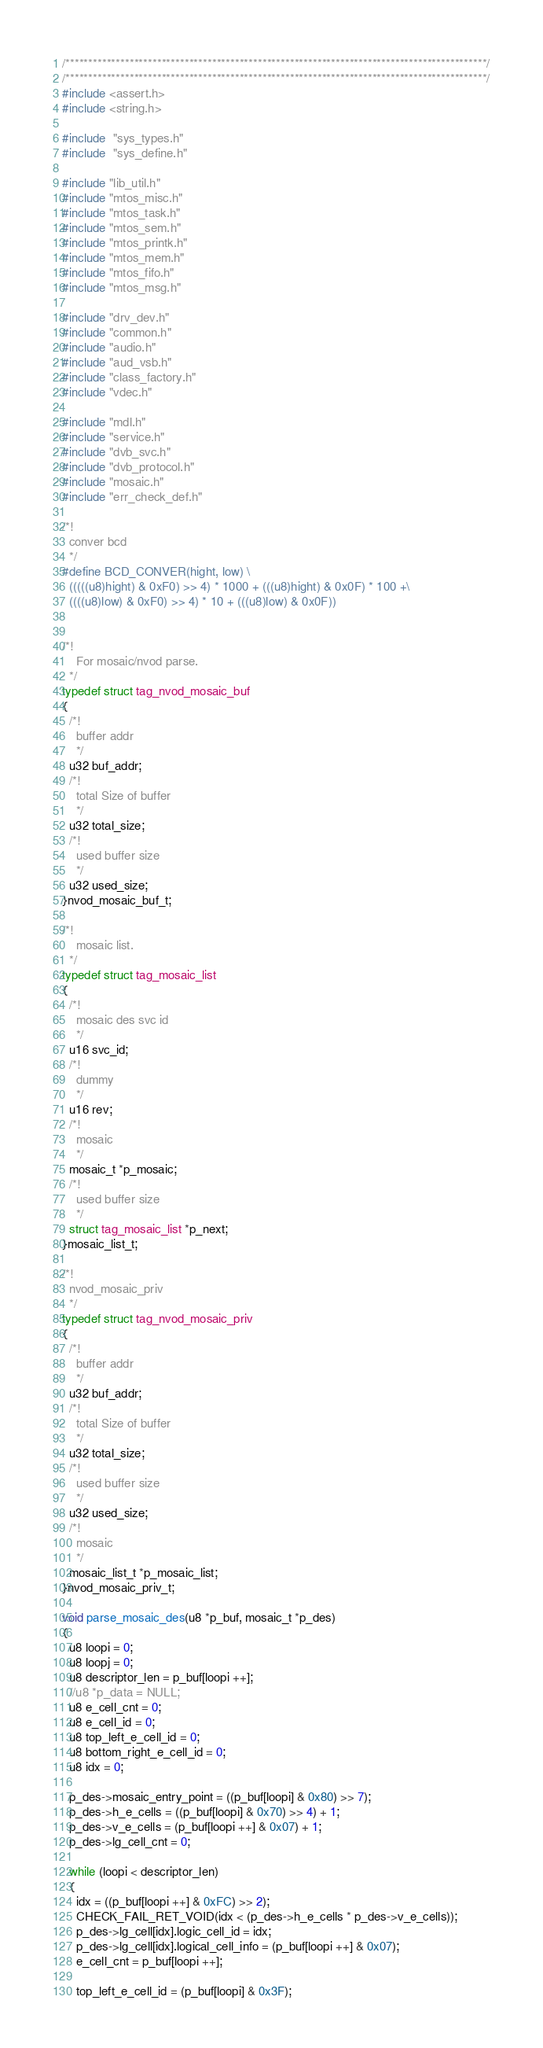Convert code to text. <code><loc_0><loc_0><loc_500><loc_500><_C_>/********************************************************************************************/
/********************************************************************************************/
#include <assert.h>
#include <string.h>

#include  "sys_types.h"
#include  "sys_define.h"

#include "lib_util.h"
#include "mtos_misc.h"
#include "mtos_task.h"
#include "mtos_sem.h"
#include "mtos_printk.h"
#include "mtos_mem.h"
#include "mtos_fifo.h"
#include "mtos_msg.h"

#include "drv_dev.h"
#include "common.h"
#include "audio.h"
#include "aud_vsb.h"
#include "class_factory.h"
#include "vdec.h"

#include "mdl.h"
#include "service.h"
#include "dvb_svc.h"
#include "dvb_protocol.h"
#include "mosaic.h"
#include "err_check_def.h"

/*!
  conver bcd
  */
#define BCD_CONVER(hight, low) \
  (((((u8)hight) & 0xF0) >> 4) * 1000 + (((u8)hight) & 0x0F) * 100 +\
  ((((u8)low) & 0xF0) >> 4) * 10 + (((u8)low) & 0x0F)) 


/*!
    For mosaic/nvod parse.  
  */
typedef struct tag_nvod_mosaic_buf
{
  /*!
    buffer addr
    */
  u32 buf_addr;
  /*!
    total Size of buffer
    */
  u32 total_size;
  /*!
    used buffer size
    */
  u32 used_size;
}nvod_mosaic_buf_t;

/*!
    mosaic list.  
  */
typedef struct tag_mosaic_list
{
  /*!
    mosaic des svc id
    */
  u16 svc_id;
  /*!
    dummy
    */
  u16 rev;
  /*!
    mosaic
    */
  mosaic_t *p_mosaic;
  /*!
    used buffer size
    */
  struct tag_mosaic_list *p_next;
}mosaic_list_t;

/*!
  nvod_mosaic_priv
  */
typedef struct tag_nvod_mosaic_priv
{
  /*!
    buffer addr
    */
  u32 buf_addr;
  /*!
    total Size of buffer
    */
  u32 total_size;
  /*!
    used buffer size
    */
  u32 used_size;
  /*!
    mosaic
    */
  mosaic_list_t *p_mosaic_list;
}nvod_mosaic_priv_t;

void parse_mosaic_des(u8 *p_buf, mosaic_t *p_des)
{
  u8 loopi = 0;
  u8 loopj = 0;
  u8 descriptor_len = p_buf[loopi ++];
  //u8 *p_data = NULL;
  u8 e_cell_cnt = 0;
  u8 e_cell_id = 0;
  u8 top_left_e_cell_id = 0;
  u8 bottom_right_e_cell_id = 0;
  u8 idx = 0;
 
  p_des->mosaic_entry_point = ((p_buf[loopi] & 0x80) >> 7);
  p_des->h_e_cells = ((p_buf[loopi] & 0x70) >> 4) + 1;
  p_des->v_e_cells = (p_buf[loopi ++] & 0x07) + 1;
  p_des->lg_cell_cnt = 0;

  while (loopi < descriptor_len)
  {
    idx = ((p_buf[loopi ++] & 0xFC) >> 2);
    CHECK_FAIL_RET_VOID(idx < (p_des->h_e_cells * p_des->v_e_cells));
    p_des->lg_cell[idx].logic_cell_id = idx;
    p_des->lg_cell[idx].logical_cell_info = (p_buf[loopi ++] & 0x07);
    e_cell_cnt = p_buf[loopi ++];
    
    top_left_e_cell_id = (p_buf[loopi] & 0x3F);</code> 